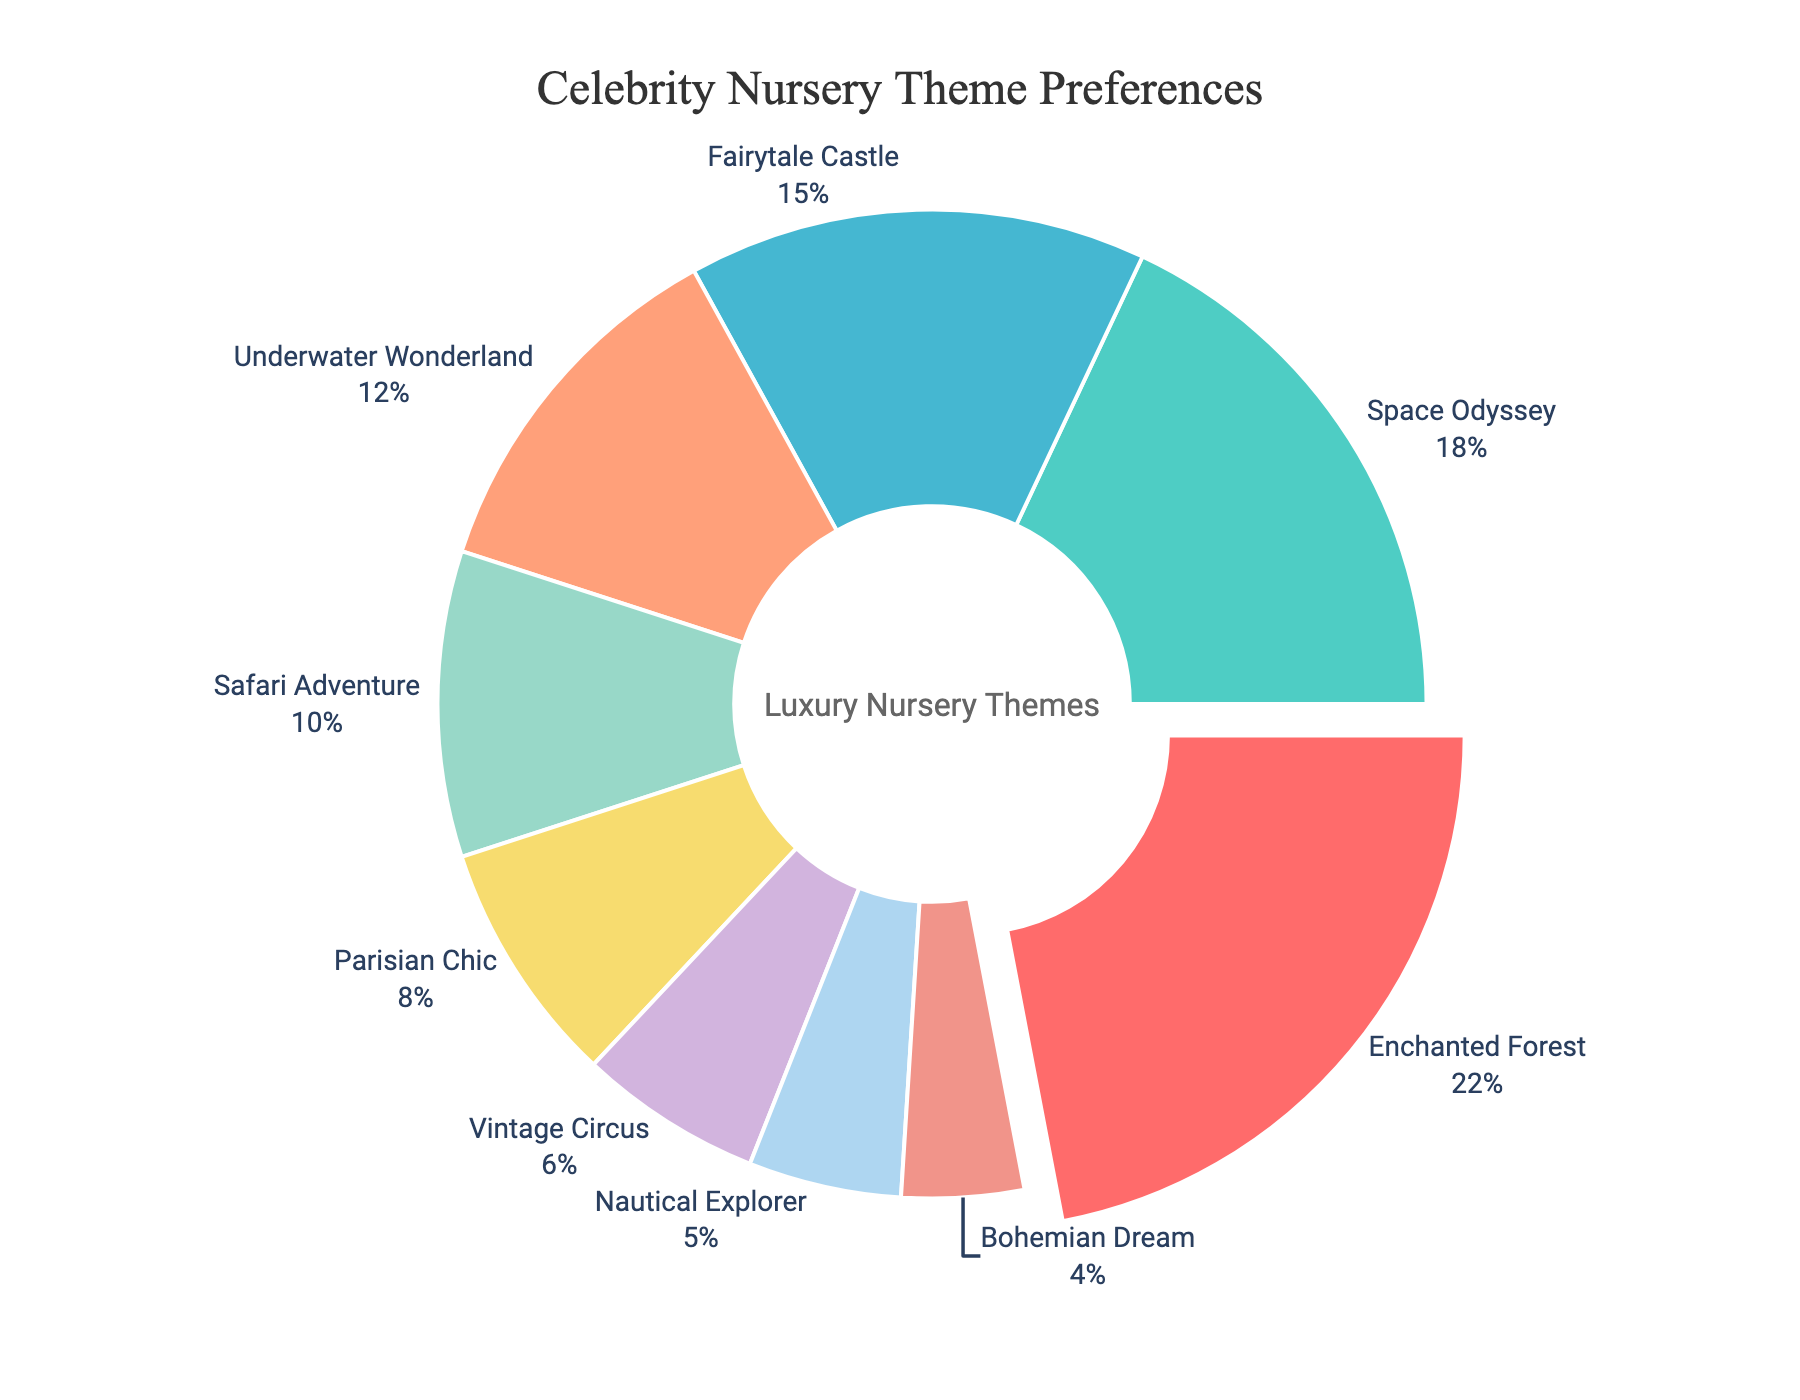What percentage of nursery themes are space-related (Space Odyssey + Underwater Wonderland)? Identify the percentages of "Space Odyssey" (18%) and "Underwater Wonderland" (12%). Summing them gives 18% + 12% = 30%.
Answer: 30% Which nursery theme is the most popular among celebrity clients? The largest segment of the pie chart, which is also pulled out slightly, corresponds to the "Enchanted Forest" theme at 22%.
Answer: Enchanted Forest How much more popular is the Fairytale Castle theme compared to the Bohemian Dream theme? Compare the percentages: Fairytale Castle is at 15%, and Bohemian Dream is at 4%. The difference is 15% - 4% = 11%.
Answer: 11% What is the least popular nursery theme? The smallest segment in the pie chart is attributed to the "Bohemian Dream" theme at 4%.
Answer: Bohemian Dream What is the combined percentage of the top three nursery themes? The top three themes are "Enchanted Forest" (22%), "Space Odyssey" (18%), and "Fairytale Castle" (15%). Summing them gives 22% + 18% + 15% = 55%.
Answer: 55% If we combine all themes below 10%, what is their total percentage? Combine the percentages of "Parisian Chic" (8%), "Vintage Circus" (6%), "Nautical Explorer" (5%), and "Bohemian Dream" (4%). The total is 8% + 6% + 5% + 4% = 23%.
Answer: 23% Which two themes together make up exactly 20% of the distribution? Evaluate possible combinations: "Safari Adventure" (10%) + "Parisian Chic" (8%) + "Vintage Circus" (6%) + "Nautical Explorer" (5%). Only "Safari Adventure" (10%) and "Parisian Chic" (8%) meet the requirement exactly 20%.
Answer: Safari Adventure and Nautical Explorer Which theme uses a yellow-gold color? By identifying the color associated with each segment, the theme using a warm, yellow-gold shade (Parisian Chic - (#F7DC6F)) stands out.
Answer: Parisian Chic How much more popular is Safari Adventure compared to Nautical Explorer? Compare the percentages: "Safari Adventure" is at 10% and "Nautical Explorer" is at 5%. The difference is 10% - 5% = 5%.
Answer: 5% 